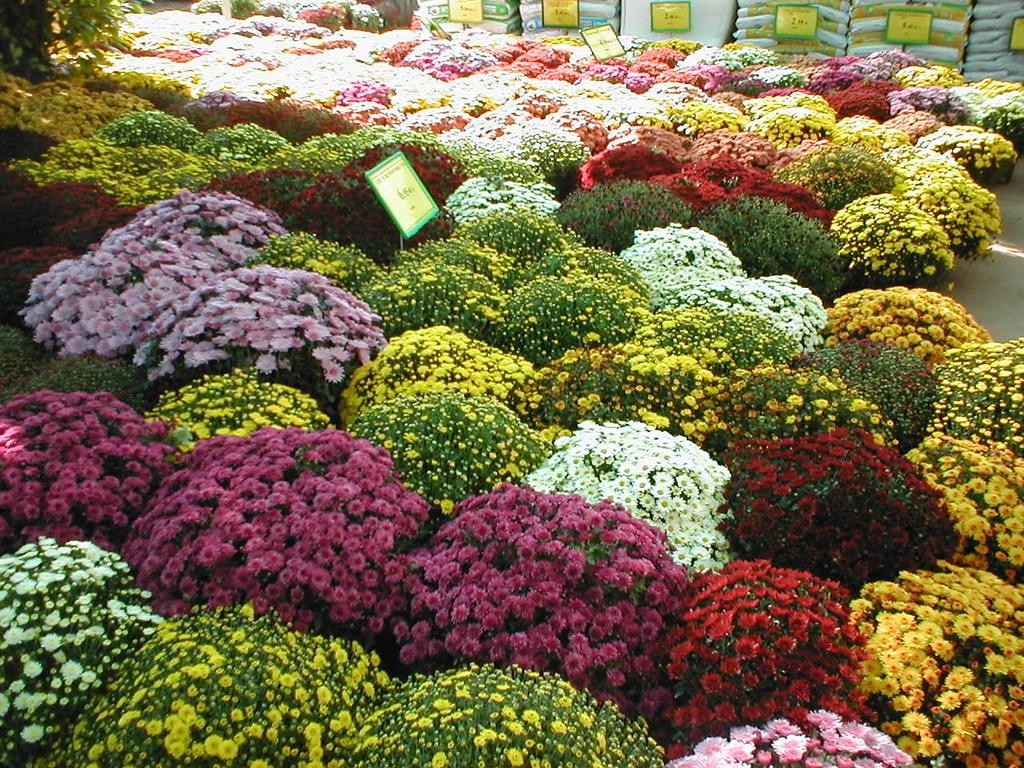What type of objects can be seen in the image? There are flower pots in the image. Can you describe the flowers in the pots? The flowers in the pots have different colors. What else is visible at the top of the image? There are bags and boards visible at the top of the image. How many pigs are present in the image? There are no pigs present in the image; it features flower pots with different colored flowers and other objects. What type of trade is being conducted in the image? There is no trade being conducted in the image; it is a still image of flower pots, bags, and boards. 